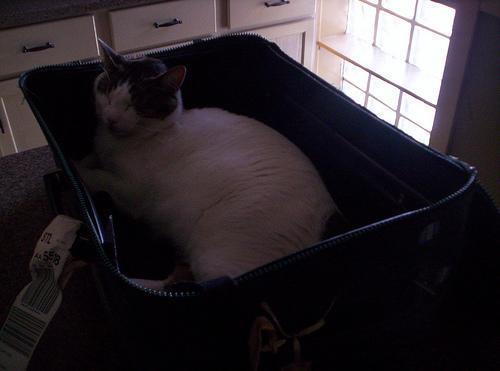How many cats are there?
Give a very brief answer. 1. How many drawers are there?
Give a very brief answer. 3. 